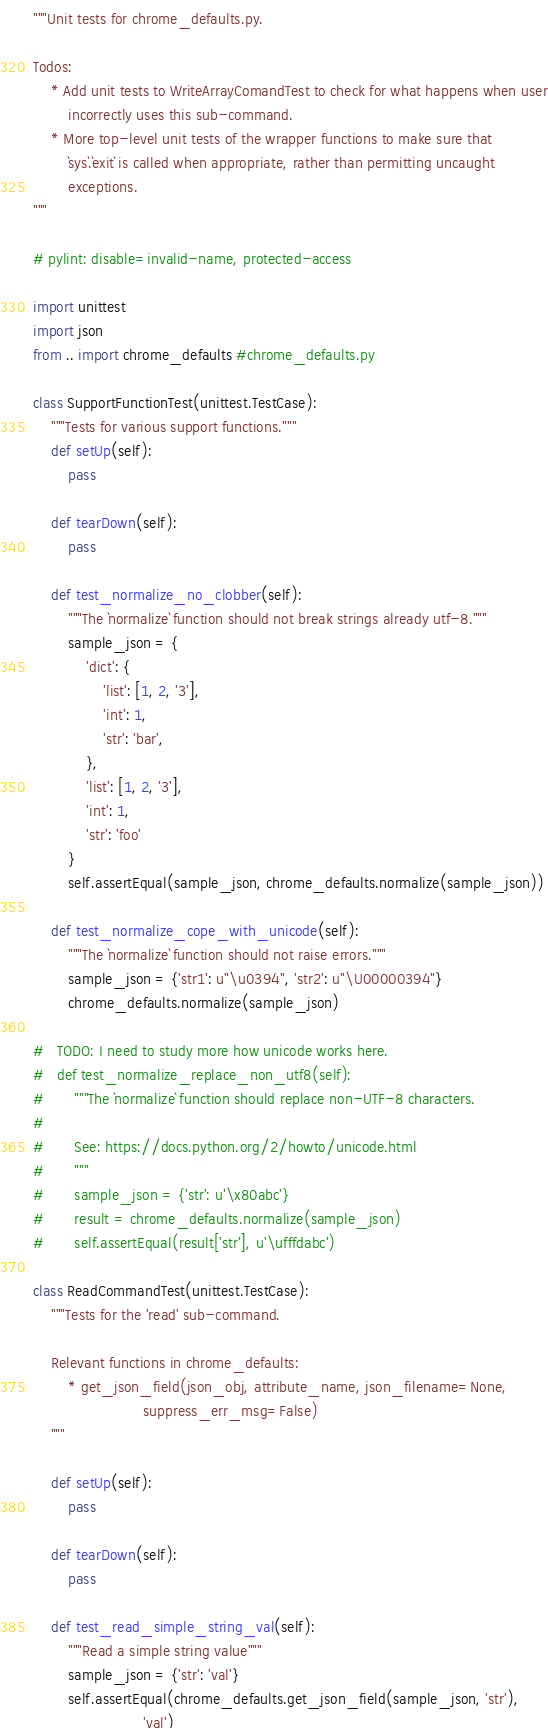<code> <loc_0><loc_0><loc_500><loc_500><_Python_>"""Unit tests for chrome_defaults.py.

Todos:
    * Add unit tests to WriteArrayComandTest to check for what happens when user
        incorrectly uses this sub-command.
    * More top-level unit tests of the wrapper functions to make sure that
        `sys`.`exit` is called when appropriate, rather than permitting uncaught
        exceptions.
"""

# pylint: disable=invalid-name, protected-access

import unittest
import json
from .. import chrome_defaults #chrome_defaults.py

class SupportFunctionTest(unittest.TestCase):
    """Tests for various support functions."""
    def setUp(self):
        pass

    def tearDown(self):
        pass

    def test_normalize_no_clobber(self):
        """The `normalize` function should not break strings already utf-8."""
        sample_json = {
            'dict': {
                'list': [1, 2, '3'],
                'int': 1,
                'str': 'bar',
            },
            'list': [1, 2, '3'],
            'int': 1,
            'str': 'foo'
        }
        self.assertEqual(sample_json, chrome_defaults.normalize(sample_json))

    def test_normalize_cope_with_unicode(self):
        """The `normalize` function should not raise errors."""
        sample_json = {'str1': u"\u0394", 'str2': u"\U00000394"}
        chrome_defaults.normalize(sample_json)

#   TODO: I need to study more how unicode works here.
#   def test_normalize_replace_non_utf8(self):
#       """The `normalize` function should replace non-UTF-8 characters.
#
#       See: https://docs.python.org/2/howto/unicode.html
#       """
#       sample_json = {'str': u'\x80abc'}
#       result = chrome_defaults.normalize(sample_json)
#       self.assertEqual(result['str'], u'\ufffdabc')

class ReadCommandTest(unittest.TestCase):
    """Tests for the 'read' sub-command.

    Relevant functions in chrome_defaults:
        * get_json_field(json_obj, attribute_name, json_filename=None,
                         suppress_err_msg=False)
    """

    def setUp(self):
        pass

    def tearDown(self):
        pass

    def test_read_simple_string_val(self):
        """Read a simple string value"""
        sample_json = {'str': 'val'}
        self.assertEqual(chrome_defaults.get_json_field(sample_json, 'str'),
                         'val')
</code> 